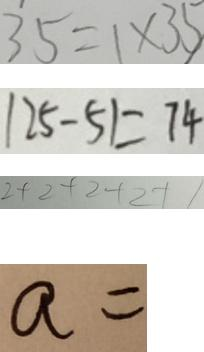<formula> <loc_0><loc_0><loc_500><loc_500>3 5 = 1 \times 3 5 
 1 2 5 - 5 1 = 7 4 
 2 + 2 + 2 + 2 + 1 
 a =</formula> 